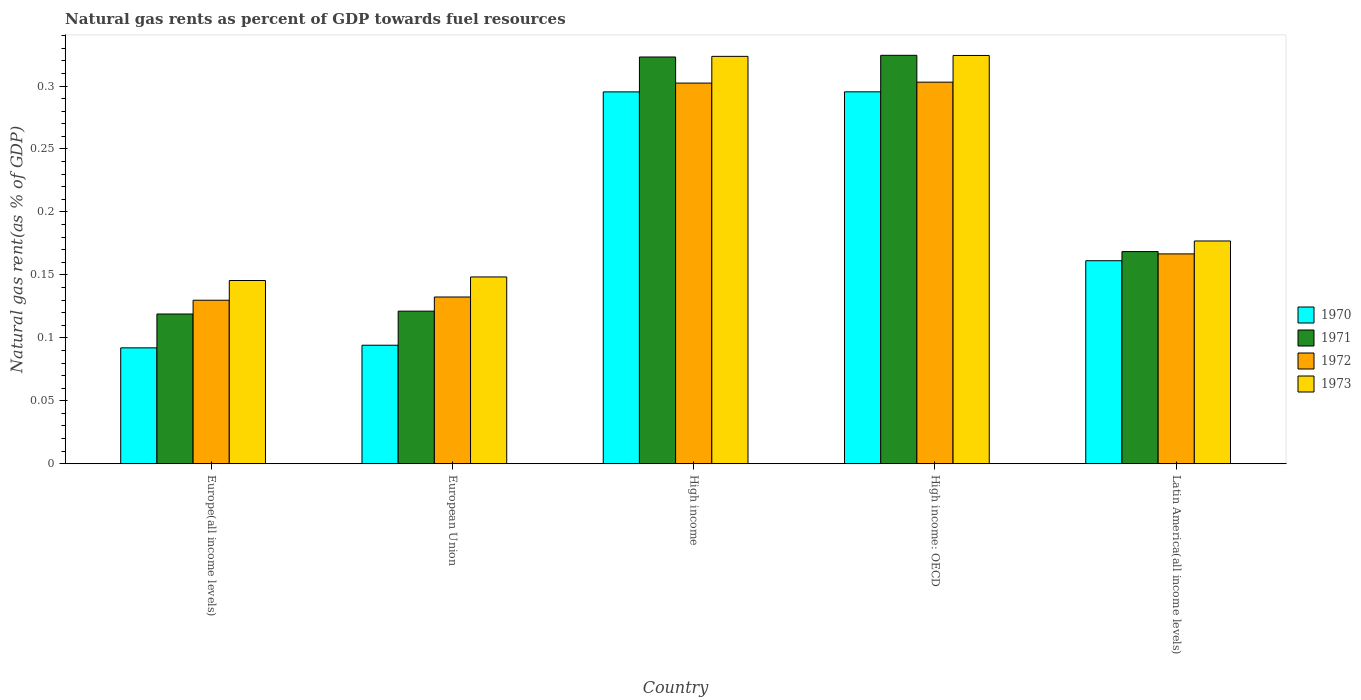How many different coloured bars are there?
Provide a short and direct response. 4. How many groups of bars are there?
Offer a terse response. 5. What is the label of the 1st group of bars from the left?
Provide a succinct answer. Europe(all income levels). What is the natural gas rent in 1972 in Latin America(all income levels)?
Provide a succinct answer. 0.17. Across all countries, what is the maximum natural gas rent in 1972?
Ensure brevity in your answer.  0.3. Across all countries, what is the minimum natural gas rent in 1970?
Offer a very short reply. 0.09. In which country was the natural gas rent in 1970 maximum?
Offer a terse response. High income: OECD. In which country was the natural gas rent in 1972 minimum?
Keep it short and to the point. Europe(all income levels). What is the total natural gas rent in 1971 in the graph?
Offer a terse response. 1.06. What is the difference between the natural gas rent in 1970 in High income: OECD and that in Latin America(all income levels)?
Ensure brevity in your answer.  0.13. What is the difference between the natural gas rent in 1970 in High income and the natural gas rent in 1971 in Latin America(all income levels)?
Offer a terse response. 0.13. What is the average natural gas rent in 1973 per country?
Keep it short and to the point. 0.22. What is the difference between the natural gas rent of/in 1971 and natural gas rent of/in 1973 in European Union?
Ensure brevity in your answer.  -0.03. What is the ratio of the natural gas rent in 1971 in Europe(all income levels) to that in High income: OECD?
Provide a succinct answer. 0.37. Is the natural gas rent in 1970 in High income less than that in Latin America(all income levels)?
Give a very brief answer. No. Is the difference between the natural gas rent in 1971 in Europe(all income levels) and High income greater than the difference between the natural gas rent in 1973 in Europe(all income levels) and High income?
Make the answer very short. No. What is the difference between the highest and the second highest natural gas rent in 1971?
Ensure brevity in your answer.  0. What is the difference between the highest and the lowest natural gas rent in 1971?
Keep it short and to the point. 0.21. Is the sum of the natural gas rent in 1970 in European Union and Latin America(all income levels) greater than the maximum natural gas rent in 1971 across all countries?
Offer a very short reply. No. Is it the case that in every country, the sum of the natural gas rent in 1973 and natural gas rent in 1972 is greater than the sum of natural gas rent in 1970 and natural gas rent in 1971?
Provide a short and direct response. No. What does the 3rd bar from the left in High income: OECD represents?
Offer a terse response. 1972. Is it the case that in every country, the sum of the natural gas rent in 1973 and natural gas rent in 1970 is greater than the natural gas rent in 1971?
Your answer should be very brief. Yes. How many bars are there?
Your answer should be very brief. 20. Are all the bars in the graph horizontal?
Your response must be concise. No. What is the difference between two consecutive major ticks on the Y-axis?
Your answer should be very brief. 0.05. Are the values on the major ticks of Y-axis written in scientific E-notation?
Provide a short and direct response. No. Does the graph contain grids?
Provide a succinct answer. No. What is the title of the graph?
Offer a very short reply. Natural gas rents as percent of GDP towards fuel resources. Does "2006" appear as one of the legend labels in the graph?
Your response must be concise. No. What is the label or title of the Y-axis?
Offer a terse response. Natural gas rent(as % of GDP). What is the Natural gas rent(as % of GDP) in 1970 in Europe(all income levels)?
Give a very brief answer. 0.09. What is the Natural gas rent(as % of GDP) of 1971 in Europe(all income levels)?
Provide a short and direct response. 0.12. What is the Natural gas rent(as % of GDP) in 1972 in Europe(all income levels)?
Keep it short and to the point. 0.13. What is the Natural gas rent(as % of GDP) in 1973 in Europe(all income levels)?
Your answer should be compact. 0.15. What is the Natural gas rent(as % of GDP) in 1970 in European Union?
Your response must be concise. 0.09. What is the Natural gas rent(as % of GDP) in 1971 in European Union?
Ensure brevity in your answer.  0.12. What is the Natural gas rent(as % of GDP) of 1972 in European Union?
Offer a very short reply. 0.13. What is the Natural gas rent(as % of GDP) of 1973 in European Union?
Offer a terse response. 0.15. What is the Natural gas rent(as % of GDP) in 1970 in High income?
Offer a very short reply. 0.3. What is the Natural gas rent(as % of GDP) of 1971 in High income?
Ensure brevity in your answer.  0.32. What is the Natural gas rent(as % of GDP) of 1972 in High income?
Ensure brevity in your answer.  0.3. What is the Natural gas rent(as % of GDP) in 1973 in High income?
Ensure brevity in your answer.  0.32. What is the Natural gas rent(as % of GDP) in 1970 in High income: OECD?
Provide a succinct answer. 0.3. What is the Natural gas rent(as % of GDP) of 1971 in High income: OECD?
Ensure brevity in your answer.  0.32. What is the Natural gas rent(as % of GDP) of 1972 in High income: OECD?
Keep it short and to the point. 0.3. What is the Natural gas rent(as % of GDP) in 1973 in High income: OECD?
Offer a terse response. 0.32. What is the Natural gas rent(as % of GDP) of 1970 in Latin America(all income levels)?
Make the answer very short. 0.16. What is the Natural gas rent(as % of GDP) in 1971 in Latin America(all income levels)?
Your answer should be compact. 0.17. What is the Natural gas rent(as % of GDP) in 1972 in Latin America(all income levels)?
Offer a terse response. 0.17. What is the Natural gas rent(as % of GDP) in 1973 in Latin America(all income levels)?
Provide a succinct answer. 0.18. Across all countries, what is the maximum Natural gas rent(as % of GDP) in 1970?
Offer a terse response. 0.3. Across all countries, what is the maximum Natural gas rent(as % of GDP) of 1971?
Ensure brevity in your answer.  0.32. Across all countries, what is the maximum Natural gas rent(as % of GDP) in 1972?
Offer a terse response. 0.3. Across all countries, what is the maximum Natural gas rent(as % of GDP) in 1973?
Offer a terse response. 0.32. Across all countries, what is the minimum Natural gas rent(as % of GDP) of 1970?
Your response must be concise. 0.09. Across all countries, what is the minimum Natural gas rent(as % of GDP) in 1971?
Offer a terse response. 0.12. Across all countries, what is the minimum Natural gas rent(as % of GDP) of 1972?
Your answer should be compact. 0.13. Across all countries, what is the minimum Natural gas rent(as % of GDP) of 1973?
Your answer should be compact. 0.15. What is the total Natural gas rent(as % of GDP) of 1970 in the graph?
Ensure brevity in your answer.  0.94. What is the total Natural gas rent(as % of GDP) of 1971 in the graph?
Make the answer very short. 1.06. What is the total Natural gas rent(as % of GDP) in 1972 in the graph?
Your answer should be compact. 1.03. What is the total Natural gas rent(as % of GDP) of 1973 in the graph?
Provide a short and direct response. 1.12. What is the difference between the Natural gas rent(as % of GDP) of 1970 in Europe(all income levels) and that in European Union?
Your response must be concise. -0. What is the difference between the Natural gas rent(as % of GDP) in 1971 in Europe(all income levels) and that in European Union?
Offer a very short reply. -0. What is the difference between the Natural gas rent(as % of GDP) of 1972 in Europe(all income levels) and that in European Union?
Keep it short and to the point. -0. What is the difference between the Natural gas rent(as % of GDP) of 1973 in Europe(all income levels) and that in European Union?
Keep it short and to the point. -0. What is the difference between the Natural gas rent(as % of GDP) of 1970 in Europe(all income levels) and that in High income?
Offer a very short reply. -0.2. What is the difference between the Natural gas rent(as % of GDP) in 1971 in Europe(all income levels) and that in High income?
Keep it short and to the point. -0.2. What is the difference between the Natural gas rent(as % of GDP) of 1972 in Europe(all income levels) and that in High income?
Offer a terse response. -0.17. What is the difference between the Natural gas rent(as % of GDP) of 1973 in Europe(all income levels) and that in High income?
Make the answer very short. -0.18. What is the difference between the Natural gas rent(as % of GDP) of 1970 in Europe(all income levels) and that in High income: OECD?
Give a very brief answer. -0.2. What is the difference between the Natural gas rent(as % of GDP) in 1971 in Europe(all income levels) and that in High income: OECD?
Ensure brevity in your answer.  -0.21. What is the difference between the Natural gas rent(as % of GDP) of 1972 in Europe(all income levels) and that in High income: OECD?
Give a very brief answer. -0.17. What is the difference between the Natural gas rent(as % of GDP) in 1973 in Europe(all income levels) and that in High income: OECD?
Your response must be concise. -0.18. What is the difference between the Natural gas rent(as % of GDP) in 1970 in Europe(all income levels) and that in Latin America(all income levels)?
Offer a very short reply. -0.07. What is the difference between the Natural gas rent(as % of GDP) in 1971 in Europe(all income levels) and that in Latin America(all income levels)?
Keep it short and to the point. -0.05. What is the difference between the Natural gas rent(as % of GDP) in 1972 in Europe(all income levels) and that in Latin America(all income levels)?
Keep it short and to the point. -0.04. What is the difference between the Natural gas rent(as % of GDP) in 1973 in Europe(all income levels) and that in Latin America(all income levels)?
Offer a very short reply. -0.03. What is the difference between the Natural gas rent(as % of GDP) of 1970 in European Union and that in High income?
Your response must be concise. -0.2. What is the difference between the Natural gas rent(as % of GDP) in 1971 in European Union and that in High income?
Provide a succinct answer. -0.2. What is the difference between the Natural gas rent(as % of GDP) in 1972 in European Union and that in High income?
Your answer should be very brief. -0.17. What is the difference between the Natural gas rent(as % of GDP) in 1973 in European Union and that in High income?
Give a very brief answer. -0.18. What is the difference between the Natural gas rent(as % of GDP) in 1970 in European Union and that in High income: OECD?
Make the answer very short. -0.2. What is the difference between the Natural gas rent(as % of GDP) of 1971 in European Union and that in High income: OECD?
Your answer should be compact. -0.2. What is the difference between the Natural gas rent(as % of GDP) of 1972 in European Union and that in High income: OECD?
Your response must be concise. -0.17. What is the difference between the Natural gas rent(as % of GDP) of 1973 in European Union and that in High income: OECD?
Offer a very short reply. -0.18. What is the difference between the Natural gas rent(as % of GDP) of 1970 in European Union and that in Latin America(all income levels)?
Ensure brevity in your answer.  -0.07. What is the difference between the Natural gas rent(as % of GDP) of 1971 in European Union and that in Latin America(all income levels)?
Keep it short and to the point. -0.05. What is the difference between the Natural gas rent(as % of GDP) in 1972 in European Union and that in Latin America(all income levels)?
Offer a terse response. -0.03. What is the difference between the Natural gas rent(as % of GDP) in 1973 in European Union and that in Latin America(all income levels)?
Your answer should be compact. -0.03. What is the difference between the Natural gas rent(as % of GDP) in 1970 in High income and that in High income: OECD?
Ensure brevity in your answer.  -0. What is the difference between the Natural gas rent(as % of GDP) of 1971 in High income and that in High income: OECD?
Offer a terse response. -0. What is the difference between the Natural gas rent(as % of GDP) of 1972 in High income and that in High income: OECD?
Make the answer very short. -0. What is the difference between the Natural gas rent(as % of GDP) of 1973 in High income and that in High income: OECD?
Keep it short and to the point. -0. What is the difference between the Natural gas rent(as % of GDP) of 1970 in High income and that in Latin America(all income levels)?
Provide a short and direct response. 0.13. What is the difference between the Natural gas rent(as % of GDP) of 1971 in High income and that in Latin America(all income levels)?
Offer a terse response. 0.15. What is the difference between the Natural gas rent(as % of GDP) of 1972 in High income and that in Latin America(all income levels)?
Ensure brevity in your answer.  0.14. What is the difference between the Natural gas rent(as % of GDP) in 1973 in High income and that in Latin America(all income levels)?
Keep it short and to the point. 0.15. What is the difference between the Natural gas rent(as % of GDP) in 1970 in High income: OECD and that in Latin America(all income levels)?
Provide a succinct answer. 0.13. What is the difference between the Natural gas rent(as % of GDP) in 1971 in High income: OECD and that in Latin America(all income levels)?
Offer a very short reply. 0.16. What is the difference between the Natural gas rent(as % of GDP) of 1972 in High income: OECD and that in Latin America(all income levels)?
Provide a short and direct response. 0.14. What is the difference between the Natural gas rent(as % of GDP) of 1973 in High income: OECD and that in Latin America(all income levels)?
Provide a succinct answer. 0.15. What is the difference between the Natural gas rent(as % of GDP) in 1970 in Europe(all income levels) and the Natural gas rent(as % of GDP) in 1971 in European Union?
Offer a terse response. -0.03. What is the difference between the Natural gas rent(as % of GDP) in 1970 in Europe(all income levels) and the Natural gas rent(as % of GDP) in 1972 in European Union?
Your answer should be compact. -0.04. What is the difference between the Natural gas rent(as % of GDP) of 1970 in Europe(all income levels) and the Natural gas rent(as % of GDP) of 1973 in European Union?
Your response must be concise. -0.06. What is the difference between the Natural gas rent(as % of GDP) of 1971 in Europe(all income levels) and the Natural gas rent(as % of GDP) of 1972 in European Union?
Make the answer very short. -0.01. What is the difference between the Natural gas rent(as % of GDP) of 1971 in Europe(all income levels) and the Natural gas rent(as % of GDP) of 1973 in European Union?
Your answer should be compact. -0.03. What is the difference between the Natural gas rent(as % of GDP) in 1972 in Europe(all income levels) and the Natural gas rent(as % of GDP) in 1973 in European Union?
Provide a succinct answer. -0.02. What is the difference between the Natural gas rent(as % of GDP) in 1970 in Europe(all income levels) and the Natural gas rent(as % of GDP) in 1971 in High income?
Keep it short and to the point. -0.23. What is the difference between the Natural gas rent(as % of GDP) of 1970 in Europe(all income levels) and the Natural gas rent(as % of GDP) of 1972 in High income?
Offer a very short reply. -0.21. What is the difference between the Natural gas rent(as % of GDP) in 1970 in Europe(all income levels) and the Natural gas rent(as % of GDP) in 1973 in High income?
Make the answer very short. -0.23. What is the difference between the Natural gas rent(as % of GDP) in 1971 in Europe(all income levels) and the Natural gas rent(as % of GDP) in 1972 in High income?
Your answer should be compact. -0.18. What is the difference between the Natural gas rent(as % of GDP) in 1971 in Europe(all income levels) and the Natural gas rent(as % of GDP) in 1973 in High income?
Keep it short and to the point. -0.2. What is the difference between the Natural gas rent(as % of GDP) in 1972 in Europe(all income levels) and the Natural gas rent(as % of GDP) in 1973 in High income?
Keep it short and to the point. -0.19. What is the difference between the Natural gas rent(as % of GDP) of 1970 in Europe(all income levels) and the Natural gas rent(as % of GDP) of 1971 in High income: OECD?
Keep it short and to the point. -0.23. What is the difference between the Natural gas rent(as % of GDP) of 1970 in Europe(all income levels) and the Natural gas rent(as % of GDP) of 1972 in High income: OECD?
Make the answer very short. -0.21. What is the difference between the Natural gas rent(as % of GDP) of 1970 in Europe(all income levels) and the Natural gas rent(as % of GDP) of 1973 in High income: OECD?
Ensure brevity in your answer.  -0.23. What is the difference between the Natural gas rent(as % of GDP) in 1971 in Europe(all income levels) and the Natural gas rent(as % of GDP) in 1972 in High income: OECD?
Your response must be concise. -0.18. What is the difference between the Natural gas rent(as % of GDP) of 1971 in Europe(all income levels) and the Natural gas rent(as % of GDP) of 1973 in High income: OECD?
Provide a succinct answer. -0.21. What is the difference between the Natural gas rent(as % of GDP) of 1972 in Europe(all income levels) and the Natural gas rent(as % of GDP) of 1973 in High income: OECD?
Offer a very short reply. -0.19. What is the difference between the Natural gas rent(as % of GDP) in 1970 in Europe(all income levels) and the Natural gas rent(as % of GDP) in 1971 in Latin America(all income levels)?
Make the answer very short. -0.08. What is the difference between the Natural gas rent(as % of GDP) in 1970 in Europe(all income levels) and the Natural gas rent(as % of GDP) in 1972 in Latin America(all income levels)?
Provide a succinct answer. -0.07. What is the difference between the Natural gas rent(as % of GDP) of 1970 in Europe(all income levels) and the Natural gas rent(as % of GDP) of 1973 in Latin America(all income levels)?
Your response must be concise. -0.08. What is the difference between the Natural gas rent(as % of GDP) in 1971 in Europe(all income levels) and the Natural gas rent(as % of GDP) in 1972 in Latin America(all income levels)?
Your answer should be very brief. -0.05. What is the difference between the Natural gas rent(as % of GDP) of 1971 in Europe(all income levels) and the Natural gas rent(as % of GDP) of 1973 in Latin America(all income levels)?
Make the answer very short. -0.06. What is the difference between the Natural gas rent(as % of GDP) of 1972 in Europe(all income levels) and the Natural gas rent(as % of GDP) of 1973 in Latin America(all income levels)?
Your answer should be compact. -0.05. What is the difference between the Natural gas rent(as % of GDP) in 1970 in European Union and the Natural gas rent(as % of GDP) in 1971 in High income?
Make the answer very short. -0.23. What is the difference between the Natural gas rent(as % of GDP) in 1970 in European Union and the Natural gas rent(as % of GDP) in 1972 in High income?
Provide a short and direct response. -0.21. What is the difference between the Natural gas rent(as % of GDP) in 1970 in European Union and the Natural gas rent(as % of GDP) in 1973 in High income?
Your answer should be compact. -0.23. What is the difference between the Natural gas rent(as % of GDP) in 1971 in European Union and the Natural gas rent(as % of GDP) in 1972 in High income?
Provide a short and direct response. -0.18. What is the difference between the Natural gas rent(as % of GDP) of 1971 in European Union and the Natural gas rent(as % of GDP) of 1973 in High income?
Your answer should be compact. -0.2. What is the difference between the Natural gas rent(as % of GDP) in 1972 in European Union and the Natural gas rent(as % of GDP) in 1973 in High income?
Ensure brevity in your answer.  -0.19. What is the difference between the Natural gas rent(as % of GDP) in 1970 in European Union and the Natural gas rent(as % of GDP) in 1971 in High income: OECD?
Keep it short and to the point. -0.23. What is the difference between the Natural gas rent(as % of GDP) of 1970 in European Union and the Natural gas rent(as % of GDP) of 1972 in High income: OECD?
Provide a short and direct response. -0.21. What is the difference between the Natural gas rent(as % of GDP) in 1970 in European Union and the Natural gas rent(as % of GDP) in 1973 in High income: OECD?
Make the answer very short. -0.23. What is the difference between the Natural gas rent(as % of GDP) in 1971 in European Union and the Natural gas rent(as % of GDP) in 1972 in High income: OECD?
Your answer should be very brief. -0.18. What is the difference between the Natural gas rent(as % of GDP) in 1971 in European Union and the Natural gas rent(as % of GDP) in 1973 in High income: OECD?
Keep it short and to the point. -0.2. What is the difference between the Natural gas rent(as % of GDP) in 1972 in European Union and the Natural gas rent(as % of GDP) in 1973 in High income: OECD?
Provide a short and direct response. -0.19. What is the difference between the Natural gas rent(as % of GDP) of 1970 in European Union and the Natural gas rent(as % of GDP) of 1971 in Latin America(all income levels)?
Your response must be concise. -0.07. What is the difference between the Natural gas rent(as % of GDP) of 1970 in European Union and the Natural gas rent(as % of GDP) of 1972 in Latin America(all income levels)?
Offer a terse response. -0.07. What is the difference between the Natural gas rent(as % of GDP) of 1970 in European Union and the Natural gas rent(as % of GDP) of 1973 in Latin America(all income levels)?
Offer a terse response. -0.08. What is the difference between the Natural gas rent(as % of GDP) of 1971 in European Union and the Natural gas rent(as % of GDP) of 1972 in Latin America(all income levels)?
Offer a very short reply. -0.05. What is the difference between the Natural gas rent(as % of GDP) of 1971 in European Union and the Natural gas rent(as % of GDP) of 1973 in Latin America(all income levels)?
Make the answer very short. -0.06. What is the difference between the Natural gas rent(as % of GDP) of 1972 in European Union and the Natural gas rent(as % of GDP) of 1973 in Latin America(all income levels)?
Offer a terse response. -0.04. What is the difference between the Natural gas rent(as % of GDP) of 1970 in High income and the Natural gas rent(as % of GDP) of 1971 in High income: OECD?
Give a very brief answer. -0.03. What is the difference between the Natural gas rent(as % of GDP) of 1970 in High income and the Natural gas rent(as % of GDP) of 1972 in High income: OECD?
Keep it short and to the point. -0.01. What is the difference between the Natural gas rent(as % of GDP) of 1970 in High income and the Natural gas rent(as % of GDP) of 1973 in High income: OECD?
Offer a terse response. -0.03. What is the difference between the Natural gas rent(as % of GDP) in 1971 in High income and the Natural gas rent(as % of GDP) in 1973 in High income: OECD?
Your answer should be very brief. -0. What is the difference between the Natural gas rent(as % of GDP) of 1972 in High income and the Natural gas rent(as % of GDP) of 1973 in High income: OECD?
Provide a short and direct response. -0.02. What is the difference between the Natural gas rent(as % of GDP) in 1970 in High income and the Natural gas rent(as % of GDP) in 1971 in Latin America(all income levels)?
Give a very brief answer. 0.13. What is the difference between the Natural gas rent(as % of GDP) in 1970 in High income and the Natural gas rent(as % of GDP) in 1972 in Latin America(all income levels)?
Offer a very short reply. 0.13. What is the difference between the Natural gas rent(as % of GDP) of 1970 in High income and the Natural gas rent(as % of GDP) of 1973 in Latin America(all income levels)?
Keep it short and to the point. 0.12. What is the difference between the Natural gas rent(as % of GDP) in 1971 in High income and the Natural gas rent(as % of GDP) in 1972 in Latin America(all income levels)?
Offer a terse response. 0.16. What is the difference between the Natural gas rent(as % of GDP) in 1971 in High income and the Natural gas rent(as % of GDP) in 1973 in Latin America(all income levels)?
Offer a very short reply. 0.15. What is the difference between the Natural gas rent(as % of GDP) of 1972 in High income and the Natural gas rent(as % of GDP) of 1973 in Latin America(all income levels)?
Keep it short and to the point. 0.13. What is the difference between the Natural gas rent(as % of GDP) in 1970 in High income: OECD and the Natural gas rent(as % of GDP) in 1971 in Latin America(all income levels)?
Your response must be concise. 0.13. What is the difference between the Natural gas rent(as % of GDP) of 1970 in High income: OECD and the Natural gas rent(as % of GDP) of 1972 in Latin America(all income levels)?
Offer a terse response. 0.13. What is the difference between the Natural gas rent(as % of GDP) in 1970 in High income: OECD and the Natural gas rent(as % of GDP) in 1973 in Latin America(all income levels)?
Offer a terse response. 0.12. What is the difference between the Natural gas rent(as % of GDP) of 1971 in High income: OECD and the Natural gas rent(as % of GDP) of 1972 in Latin America(all income levels)?
Provide a succinct answer. 0.16. What is the difference between the Natural gas rent(as % of GDP) in 1971 in High income: OECD and the Natural gas rent(as % of GDP) in 1973 in Latin America(all income levels)?
Offer a terse response. 0.15. What is the difference between the Natural gas rent(as % of GDP) in 1972 in High income: OECD and the Natural gas rent(as % of GDP) in 1973 in Latin America(all income levels)?
Give a very brief answer. 0.13. What is the average Natural gas rent(as % of GDP) of 1970 per country?
Your response must be concise. 0.19. What is the average Natural gas rent(as % of GDP) in 1971 per country?
Provide a succinct answer. 0.21. What is the average Natural gas rent(as % of GDP) of 1972 per country?
Provide a short and direct response. 0.21. What is the average Natural gas rent(as % of GDP) of 1973 per country?
Provide a short and direct response. 0.22. What is the difference between the Natural gas rent(as % of GDP) of 1970 and Natural gas rent(as % of GDP) of 1971 in Europe(all income levels)?
Offer a very short reply. -0.03. What is the difference between the Natural gas rent(as % of GDP) of 1970 and Natural gas rent(as % of GDP) of 1972 in Europe(all income levels)?
Ensure brevity in your answer.  -0.04. What is the difference between the Natural gas rent(as % of GDP) of 1970 and Natural gas rent(as % of GDP) of 1973 in Europe(all income levels)?
Offer a terse response. -0.05. What is the difference between the Natural gas rent(as % of GDP) of 1971 and Natural gas rent(as % of GDP) of 1972 in Europe(all income levels)?
Provide a short and direct response. -0.01. What is the difference between the Natural gas rent(as % of GDP) of 1971 and Natural gas rent(as % of GDP) of 1973 in Europe(all income levels)?
Your answer should be compact. -0.03. What is the difference between the Natural gas rent(as % of GDP) in 1972 and Natural gas rent(as % of GDP) in 1973 in Europe(all income levels)?
Ensure brevity in your answer.  -0.02. What is the difference between the Natural gas rent(as % of GDP) of 1970 and Natural gas rent(as % of GDP) of 1971 in European Union?
Give a very brief answer. -0.03. What is the difference between the Natural gas rent(as % of GDP) of 1970 and Natural gas rent(as % of GDP) of 1972 in European Union?
Your response must be concise. -0.04. What is the difference between the Natural gas rent(as % of GDP) of 1970 and Natural gas rent(as % of GDP) of 1973 in European Union?
Provide a short and direct response. -0.05. What is the difference between the Natural gas rent(as % of GDP) of 1971 and Natural gas rent(as % of GDP) of 1972 in European Union?
Ensure brevity in your answer.  -0.01. What is the difference between the Natural gas rent(as % of GDP) of 1971 and Natural gas rent(as % of GDP) of 1973 in European Union?
Make the answer very short. -0.03. What is the difference between the Natural gas rent(as % of GDP) in 1972 and Natural gas rent(as % of GDP) in 1973 in European Union?
Your response must be concise. -0.02. What is the difference between the Natural gas rent(as % of GDP) in 1970 and Natural gas rent(as % of GDP) in 1971 in High income?
Provide a succinct answer. -0.03. What is the difference between the Natural gas rent(as % of GDP) in 1970 and Natural gas rent(as % of GDP) in 1972 in High income?
Offer a terse response. -0.01. What is the difference between the Natural gas rent(as % of GDP) in 1970 and Natural gas rent(as % of GDP) in 1973 in High income?
Provide a succinct answer. -0.03. What is the difference between the Natural gas rent(as % of GDP) of 1971 and Natural gas rent(as % of GDP) of 1972 in High income?
Provide a succinct answer. 0.02. What is the difference between the Natural gas rent(as % of GDP) of 1971 and Natural gas rent(as % of GDP) of 1973 in High income?
Offer a very short reply. -0. What is the difference between the Natural gas rent(as % of GDP) in 1972 and Natural gas rent(as % of GDP) in 1973 in High income?
Provide a short and direct response. -0.02. What is the difference between the Natural gas rent(as % of GDP) in 1970 and Natural gas rent(as % of GDP) in 1971 in High income: OECD?
Ensure brevity in your answer.  -0.03. What is the difference between the Natural gas rent(as % of GDP) in 1970 and Natural gas rent(as % of GDP) in 1972 in High income: OECD?
Your answer should be compact. -0.01. What is the difference between the Natural gas rent(as % of GDP) in 1970 and Natural gas rent(as % of GDP) in 1973 in High income: OECD?
Give a very brief answer. -0.03. What is the difference between the Natural gas rent(as % of GDP) of 1971 and Natural gas rent(as % of GDP) of 1972 in High income: OECD?
Give a very brief answer. 0.02. What is the difference between the Natural gas rent(as % of GDP) of 1971 and Natural gas rent(as % of GDP) of 1973 in High income: OECD?
Offer a very short reply. 0. What is the difference between the Natural gas rent(as % of GDP) of 1972 and Natural gas rent(as % of GDP) of 1973 in High income: OECD?
Make the answer very short. -0.02. What is the difference between the Natural gas rent(as % of GDP) of 1970 and Natural gas rent(as % of GDP) of 1971 in Latin America(all income levels)?
Your response must be concise. -0.01. What is the difference between the Natural gas rent(as % of GDP) in 1970 and Natural gas rent(as % of GDP) in 1972 in Latin America(all income levels)?
Offer a terse response. -0.01. What is the difference between the Natural gas rent(as % of GDP) in 1970 and Natural gas rent(as % of GDP) in 1973 in Latin America(all income levels)?
Your response must be concise. -0.02. What is the difference between the Natural gas rent(as % of GDP) of 1971 and Natural gas rent(as % of GDP) of 1972 in Latin America(all income levels)?
Provide a short and direct response. 0. What is the difference between the Natural gas rent(as % of GDP) in 1971 and Natural gas rent(as % of GDP) in 1973 in Latin America(all income levels)?
Offer a very short reply. -0.01. What is the difference between the Natural gas rent(as % of GDP) of 1972 and Natural gas rent(as % of GDP) of 1973 in Latin America(all income levels)?
Your response must be concise. -0.01. What is the ratio of the Natural gas rent(as % of GDP) of 1970 in Europe(all income levels) to that in European Union?
Give a very brief answer. 0.98. What is the ratio of the Natural gas rent(as % of GDP) in 1971 in Europe(all income levels) to that in European Union?
Ensure brevity in your answer.  0.98. What is the ratio of the Natural gas rent(as % of GDP) of 1972 in Europe(all income levels) to that in European Union?
Provide a succinct answer. 0.98. What is the ratio of the Natural gas rent(as % of GDP) of 1973 in Europe(all income levels) to that in European Union?
Offer a terse response. 0.98. What is the ratio of the Natural gas rent(as % of GDP) in 1970 in Europe(all income levels) to that in High income?
Provide a succinct answer. 0.31. What is the ratio of the Natural gas rent(as % of GDP) of 1971 in Europe(all income levels) to that in High income?
Ensure brevity in your answer.  0.37. What is the ratio of the Natural gas rent(as % of GDP) of 1972 in Europe(all income levels) to that in High income?
Provide a succinct answer. 0.43. What is the ratio of the Natural gas rent(as % of GDP) in 1973 in Europe(all income levels) to that in High income?
Give a very brief answer. 0.45. What is the ratio of the Natural gas rent(as % of GDP) of 1970 in Europe(all income levels) to that in High income: OECD?
Your answer should be very brief. 0.31. What is the ratio of the Natural gas rent(as % of GDP) of 1971 in Europe(all income levels) to that in High income: OECD?
Provide a short and direct response. 0.37. What is the ratio of the Natural gas rent(as % of GDP) in 1972 in Europe(all income levels) to that in High income: OECD?
Offer a very short reply. 0.43. What is the ratio of the Natural gas rent(as % of GDP) of 1973 in Europe(all income levels) to that in High income: OECD?
Your response must be concise. 0.45. What is the ratio of the Natural gas rent(as % of GDP) in 1970 in Europe(all income levels) to that in Latin America(all income levels)?
Ensure brevity in your answer.  0.57. What is the ratio of the Natural gas rent(as % of GDP) of 1971 in Europe(all income levels) to that in Latin America(all income levels)?
Your response must be concise. 0.71. What is the ratio of the Natural gas rent(as % of GDP) of 1972 in Europe(all income levels) to that in Latin America(all income levels)?
Your response must be concise. 0.78. What is the ratio of the Natural gas rent(as % of GDP) in 1973 in Europe(all income levels) to that in Latin America(all income levels)?
Your response must be concise. 0.82. What is the ratio of the Natural gas rent(as % of GDP) in 1970 in European Union to that in High income?
Your response must be concise. 0.32. What is the ratio of the Natural gas rent(as % of GDP) in 1971 in European Union to that in High income?
Your answer should be very brief. 0.38. What is the ratio of the Natural gas rent(as % of GDP) in 1972 in European Union to that in High income?
Provide a succinct answer. 0.44. What is the ratio of the Natural gas rent(as % of GDP) in 1973 in European Union to that in High income?
Your response must be concise. 0.46. What is the ratio of the Natural gas rent(as % of GDP) of 1970 in European Union to that in High income: OECD?
Offer a terse response. 0.32. What is the ratio of the Natural gas rent(as % of GDP) of 1971 in European Union to that in High income: OECD?
Keep it short and to the point. 0.37. What is the ratio of the Natural gas rent(as % of GDP) of 1972 in European Union to that in High income: OECD?
Offer a very short reply. 0.44. What is the ratio of the Natural gas rent(as % of GDP) of 1973 in European Union to that in High income: OECD?
Provide a succinct answer. 0.46. What is the ratio of the Natural gas rent(as % of GDP) of 1970 in European Union to that in Latin America(all income levels)?
Make the answer very short. 0.58. What is the ratio of the Natural gas rent(as % of GDP) in 1971 in European Union to that in Latin America(all income levels)?
Offer a very short reply. 0.72. What is the ratio of the Natural gas rent(as % of GDP) of 1972 in European Union to that in Latin America(all income levels)?
Your answer should be very brief. 0.79. What is the ratio of the Natural gas rent(as % of GDP) of 1973 in European Union to that in Latin America(all income levels)?
Provide a short and direct response. 0.84. What is the ratio of the Natural gas rent(as % of GDP) of 1971 in High income to that in High income: OECD?
Make the answer very short. 1. What is the ratio of the Natural gas rent(as % of GDP) of 1972 in High income to that in High income: OECD?
Offer a terse response. 1. What is the ratio of the Natural gas rent(as % of GDP) of 1973 in High income to that in High income: OECD?
Make the answer very short. 1. What is the ratio of the Natural gas rent(as % of GDP) of 1970 in High income to that in Latin America(all income levels)?
Give a very brief answer. 1.83. What is the ratio of the Natural gas rent(as % of GDP) of 1971 in High income to that in Latin America(all income levels)?
Ensure brevity in your answer.  1.92. What is the ratio of the Natural gas rent(as % of GDP) of 1972 in High income to that in Latin America(all income levels)?
Offer a terse response. 1.81. What is the ratio of the Natural gas rent(as % of GDP) in 1973 in High income to that in Latin America(all income levels)?
Ensure brevity in your answer.  1.83. What is the ratio of the Natural gas rent(as % of GDP) in 1970 in High income: OECD to that in Latin America(all income levels)?
Make the answer very short. 1.83. What is the ratio of the Natural gas rent(as % of GDP) of 1971 in High income: OECD to that in Latin America(all income levels)?
Your answer should be very brief. 1.93. What is the ratio of the Natural gas rent(as % of GDP) of 1972 in High income: OECD to that in Latin America(all income levels)?
Offer a very short reply. 1.82. What is the ratio of the Natural gas rent(as % of GDP) of 1973 in High income: OECD to that in Latin America(all income levels)?
Your answer should be compact. 1.83. What is the difference between the highest and the second highest Natural gas rent(as % of GDP) in 1970?
Give a very brief answer. 0. What is the difference between the highest and the second highest Natural gas rent(as % of GDP) of 1971?
Give a very brief answer. 0. What is the difference between the highest and the second highest Natural gas rent(as % of GDP) in 1972?
Provide a succinct answer. 0. What is the difference between the highest and the second highest Natural gas rent(as % of GDP) in 1973?
Offer a terse response. 0. What is the difference between the highest and the lowest Natural gas rent(as % of GDP) of 1970?
Give a very brief answer. 0.2. What is the difference between the highest and the lowest Natural gas rent(as % of GDP) of 1971?
Your answer should be very brief. 0.21. What is the difference between the highest and the lowest Natural gas rent(as % of GDP) of 1972?
Provide a short and direct response. 0.17. What is the difference between the highest and the lowest Natural gas rent(as % of GDP) of 1973?
Give a very brief answer. 0.18. 